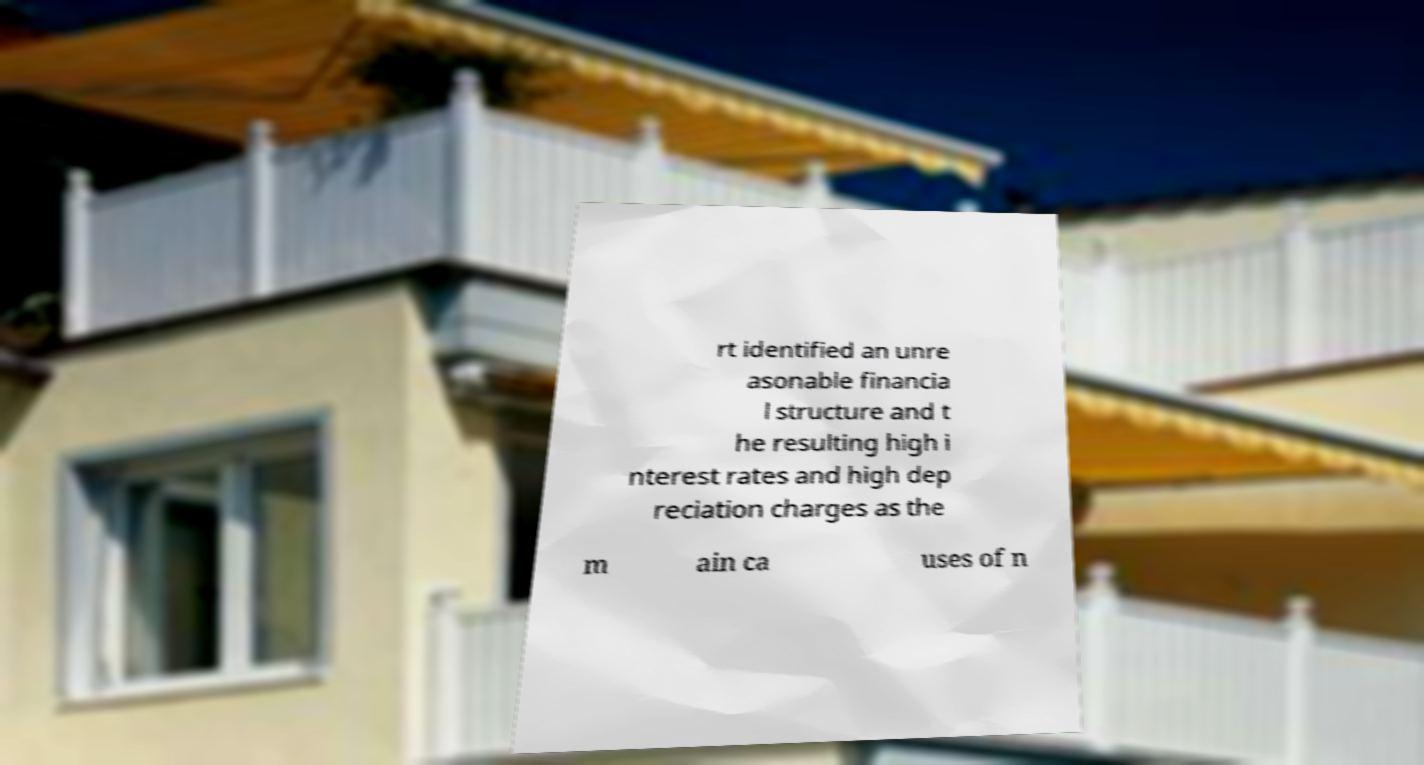There's text embedded in this image that I need extracted. Can you transcribe it verbatim? rt identified an unre asonable financia l structure and t he resulting high i nterest rates and high dep reciation charges as the m ain ca uses of n 